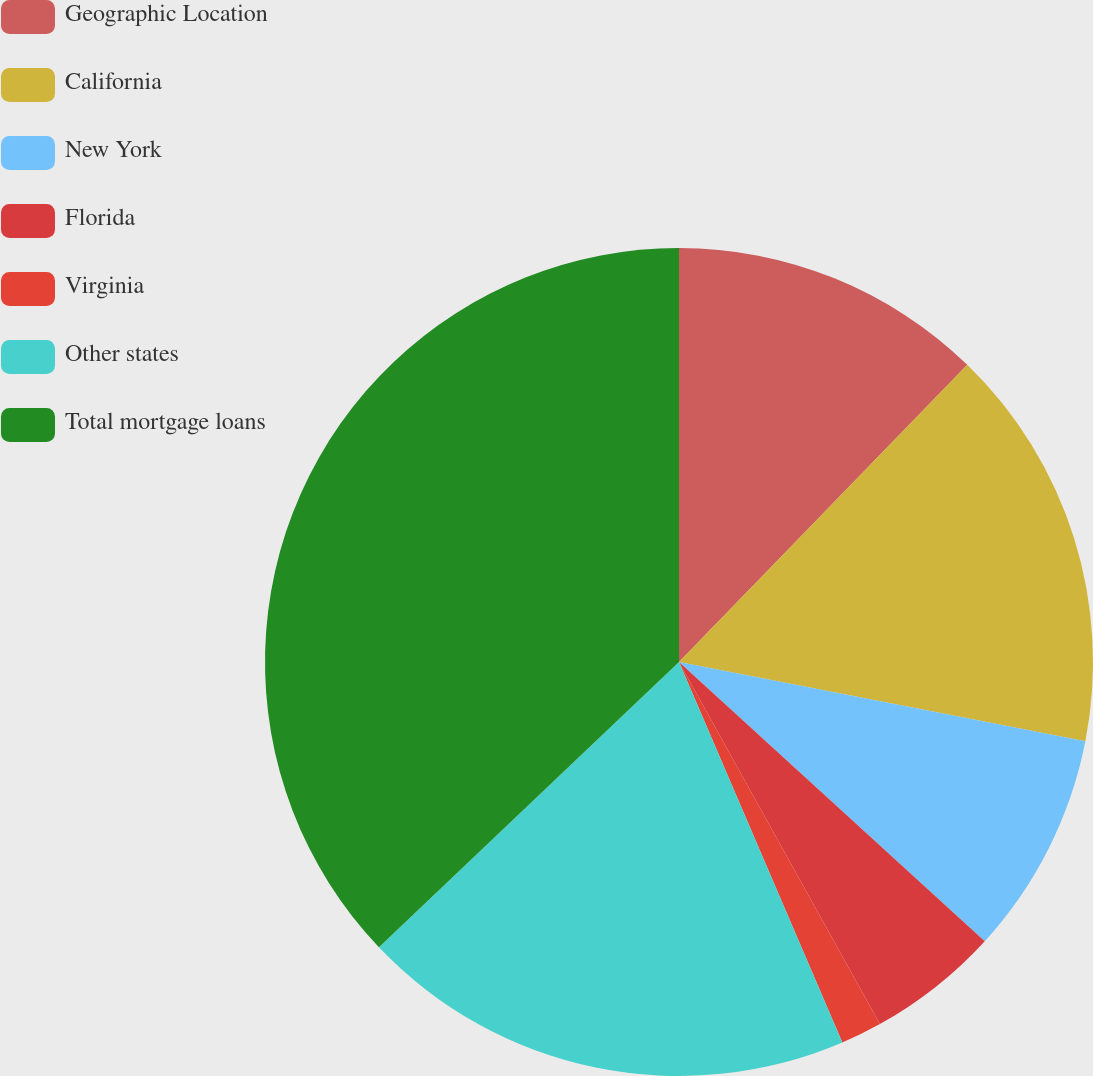Convert chart. <chart><loc_0><loc_0><loc_500><loc_500><pie_chart><fcel>Geographic Location<fcel>California<fcel>New York<fcel>Florida<fcel>Virginia<fcel>Other states<fcel>Total mortgage loans<nl><fcel>12.26%<fcel>15.81%<fcel>8.71%<fcel>5.16%<fcel>1.61%<fcel>19.36%<fcel>37.1%<nl></chart> 